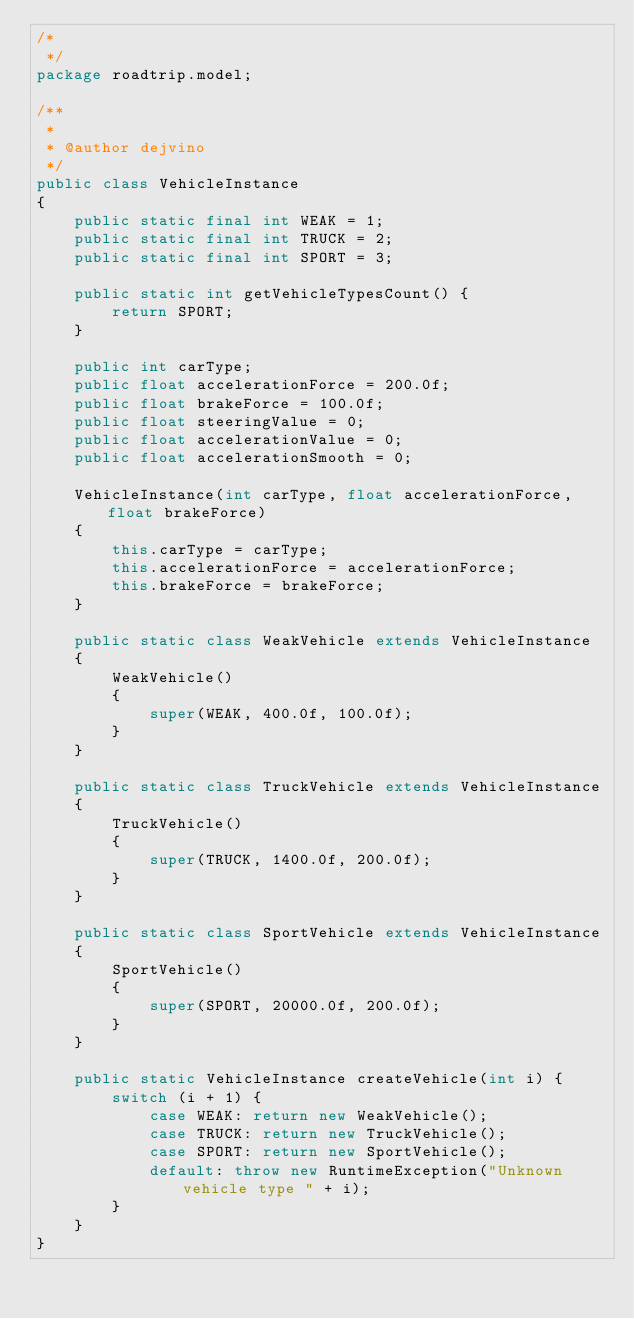Convert code to text. <code><loc_0><loc_0><loc_500><loc_500><_Java_>/*
 */
package roadtrip.model;

/**
 *
 * @author dejvino
 */
public class VehicleInstance
{
    public static final int WEAK = 1;
    public static final int TRUCK = 2;
    public static final int SPORT = 3;

    public static int getVehicleTypesCount() {
        return SPORT;
    }

    public int carType;
    public float accelerationForce = 200.0f;
    public float brakeForce = 100.0f;
    public float steeringValue = 0;
    public float accelerationValue = 0;
    public float accelerationSmooth = 0;

    VehicleInstance(int carType, float accelerationForce, float brakeForce)
    {
        this.carType = carType;
        this.accelerationForce = accelerationForce;
        this.brakeForce = brakeForce;
    }
    
    public static class WeakVehicle extends VehicleInstance
    {
        WeakVehicle()
        {
            super(WEAK, 400.0f, 100.0f);
        }
    }
    
    public static class TruckVehicle extends VehicleInstance
    {
        TruckVehicle()
        {
            super(TRUCK, 1400.0f, 200.0f);
        }
    }
    
    public static class SportVehicle extends VehicleInstance
    {
        SportVehicle()
        {
            super(SPORT, 20000.0f, 200.0f);
        }
    }
    
    public static VehicleInstance createVehicle(int i) {
        switch (i + 1) {
            case WEAK: return new WeakVehicle();
            case TRUCK: return new TruckVehicle();
            case SPORT: return new SportVehicle();
            default: throw new RuntimeException("Unknown vehicle type " + i);
        }
    }
}</code> 